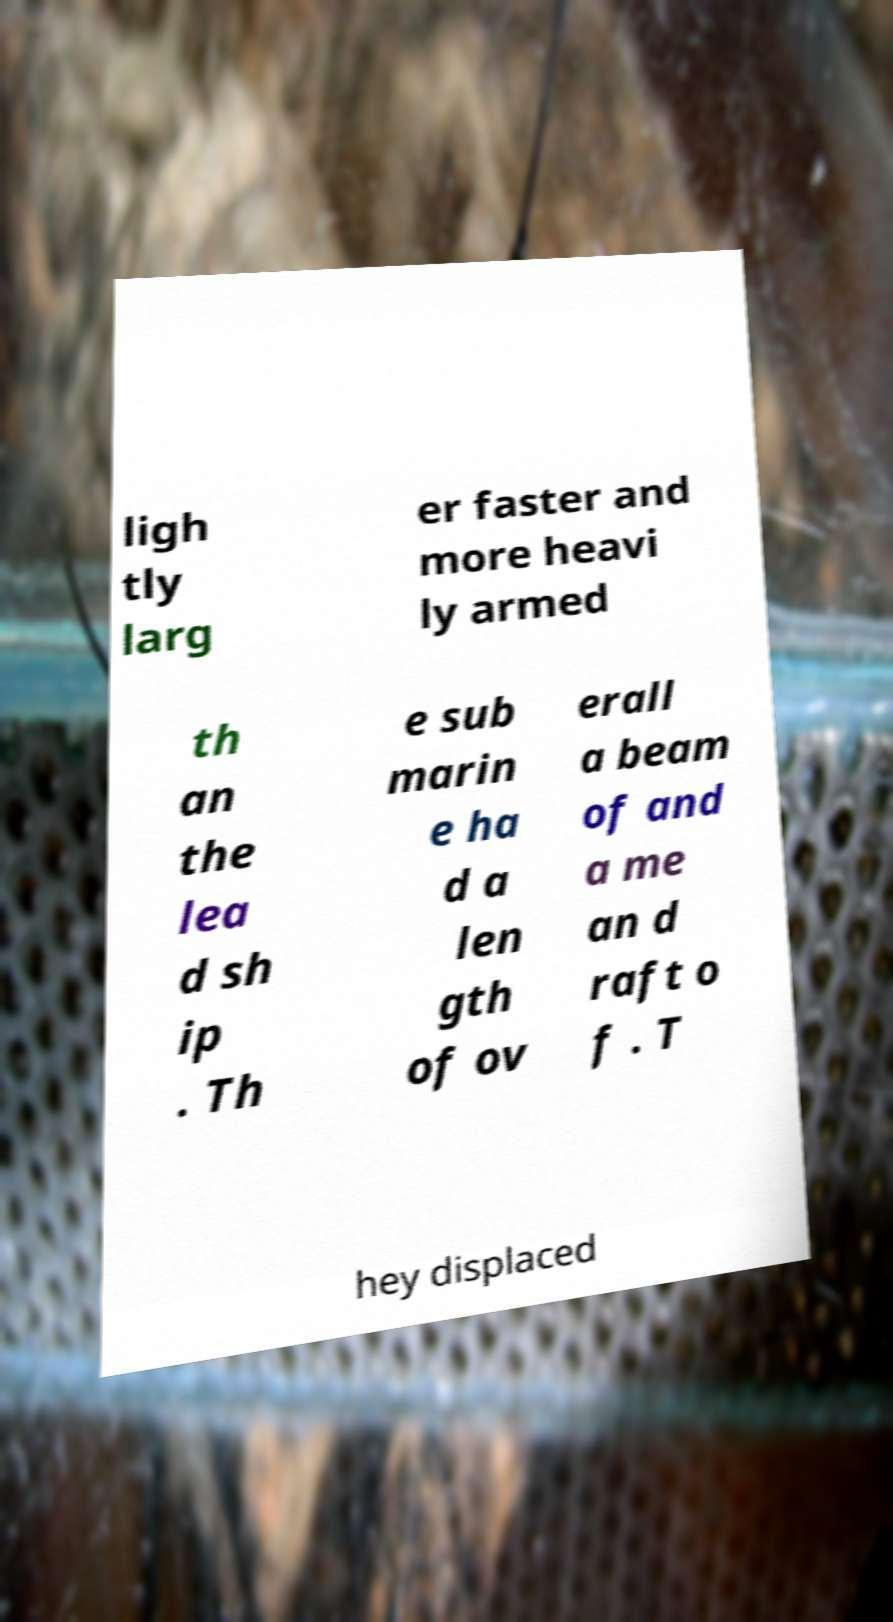What messages or text are displayed in this image? I need them in a readable, typed format. ligh tly larg er faster and more heavi ly armed th an the lea d sh ip . Th e sub marin e ha d a len gth of ov erall a beam of and a me an d raft o f . T hey displaced 